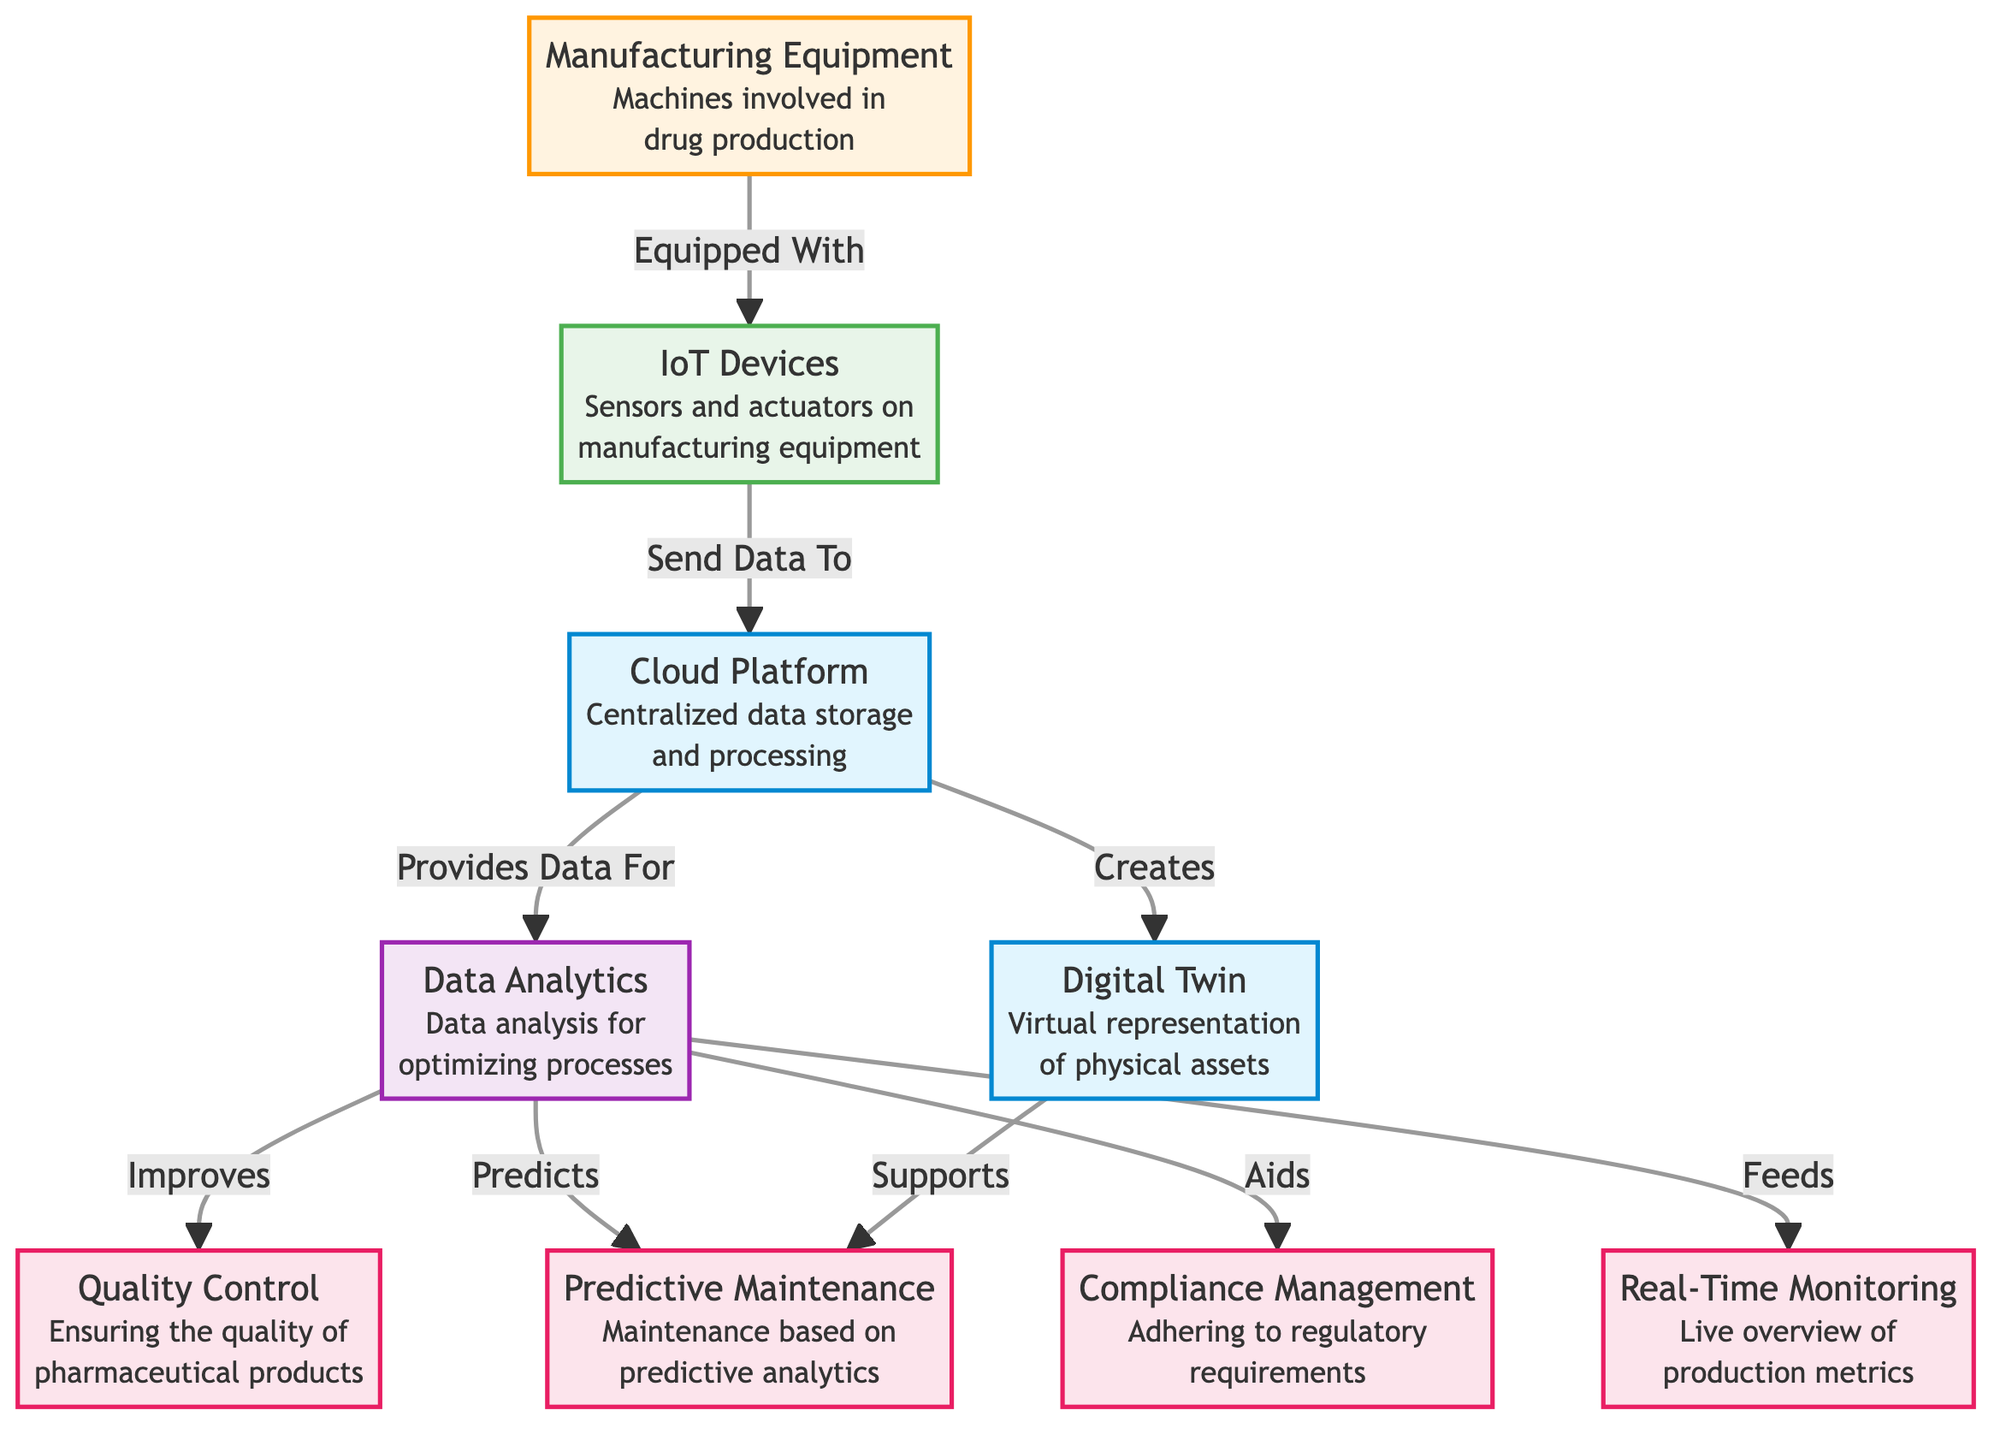What is the primary function of the cloud platform? The cloud platform serves as centralized data storage and processing, which can be seen from the description directly under the cloud platform node in the diagram.
Answer: Centralized data storage and processing How many types of processes are illustrated in the diagram? By observing the process nodes within the diagram, there are four distinct processes labeled quality control, predictive maintenance, compliance management, and real-time monitoring, which makes a total of four process types.
Answer: Four What do IoT devices send data to? The IoT devices are shown to have a direct connection to the cloud platform, sending data to it as specified by the labeled relationship in the diagram.
Answer: Cloud platform Which node aids compliance management? The data analytics node is linked to the compliance management node, indicating that it provides assistance to compliance through the labeled connection in the diagram.
Answer: Data analytics What does the digital twin support? The digital twin node is shown to support predictive maintenance as indicated by the direct relationship labeled in the diagram.
Answer: Predictive maintenance What are IoT devices used for in relation to manufacturing equipment? The diagram clearly states that IoT devices are equipped with sensors and actuators on manufacturing equipment, emphasizing their role in monitoring and controlling the machinery.
Answer: Sensors and actuators on manufacturing equipment How does data analytics improve quality control? Data analytics directly improves quality control as shown in the labeled connection between these two nodes, indicating that analysis of data leads to enhanced processes.
Answer: Improves What type of monitoring does the real-time monitoring node provide? The real-time monitoring node provides a live overview of production metrics as indicated in the description just below the node in the diagram.
Answer: Live overview of production metrics 